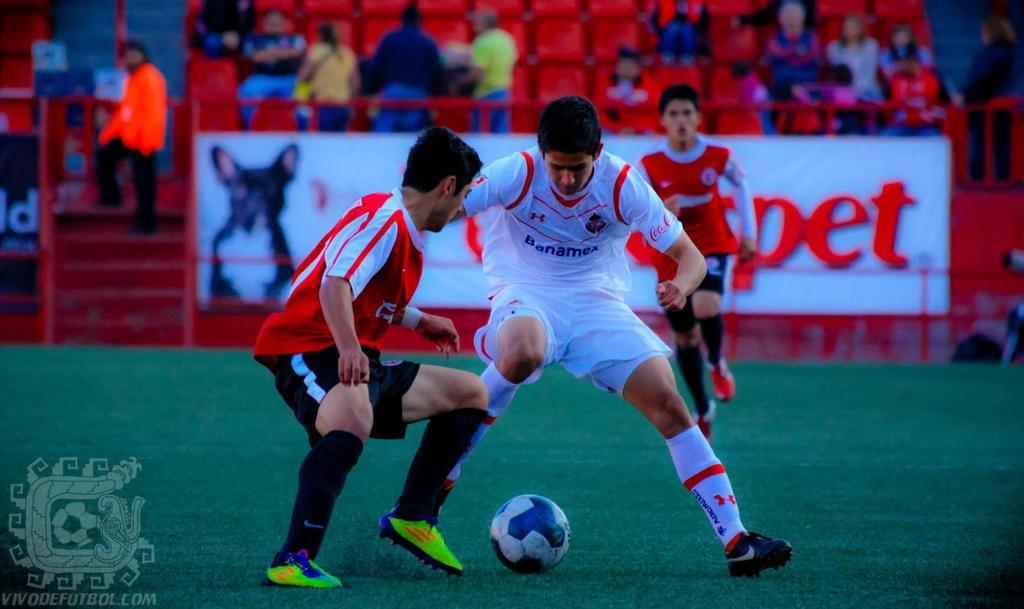<image>
Render a clear and concise summary of the photo. A man wearing Banamex's jersey is playing soccer with another team. 